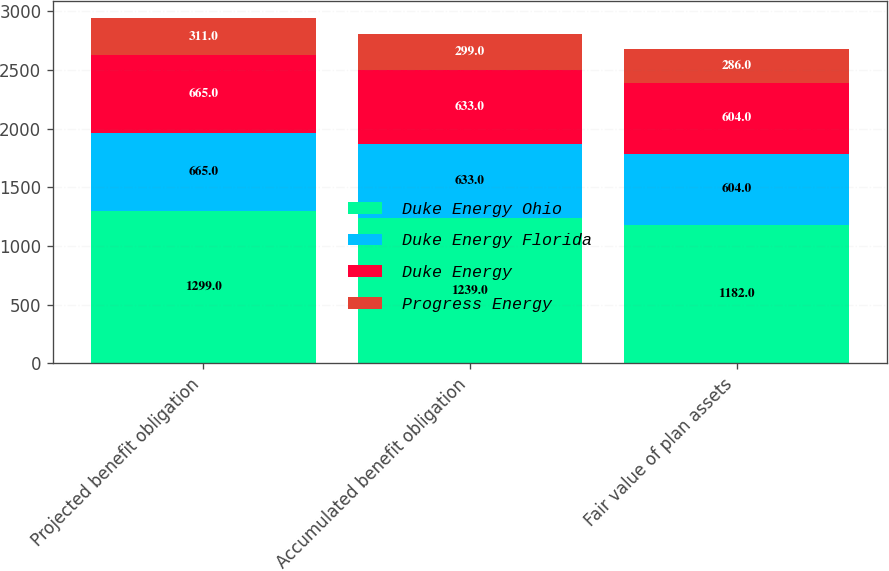Convert chart. <chart><loc_0><loc_0><loc_500><loc_500><stacked_bar_chart><ecel><fcel>Projected benefit obligation<fcel>Accumulated benefit obligation<fcel>Fair value of plan assets<nl><fcel>Duke Energy Ohio<fcel>1299<fcel>1239<fcel>1182<nl><fcel>Duke Energy Florida<fcel>665<fcel>633<fcel>604<nl><fcel>Duke Energy<fcel>665<fcel>633<fcel>604<nl><fcel>Progress Energy<fcel>311<fcel>299<fcel>286<nl></chart> 